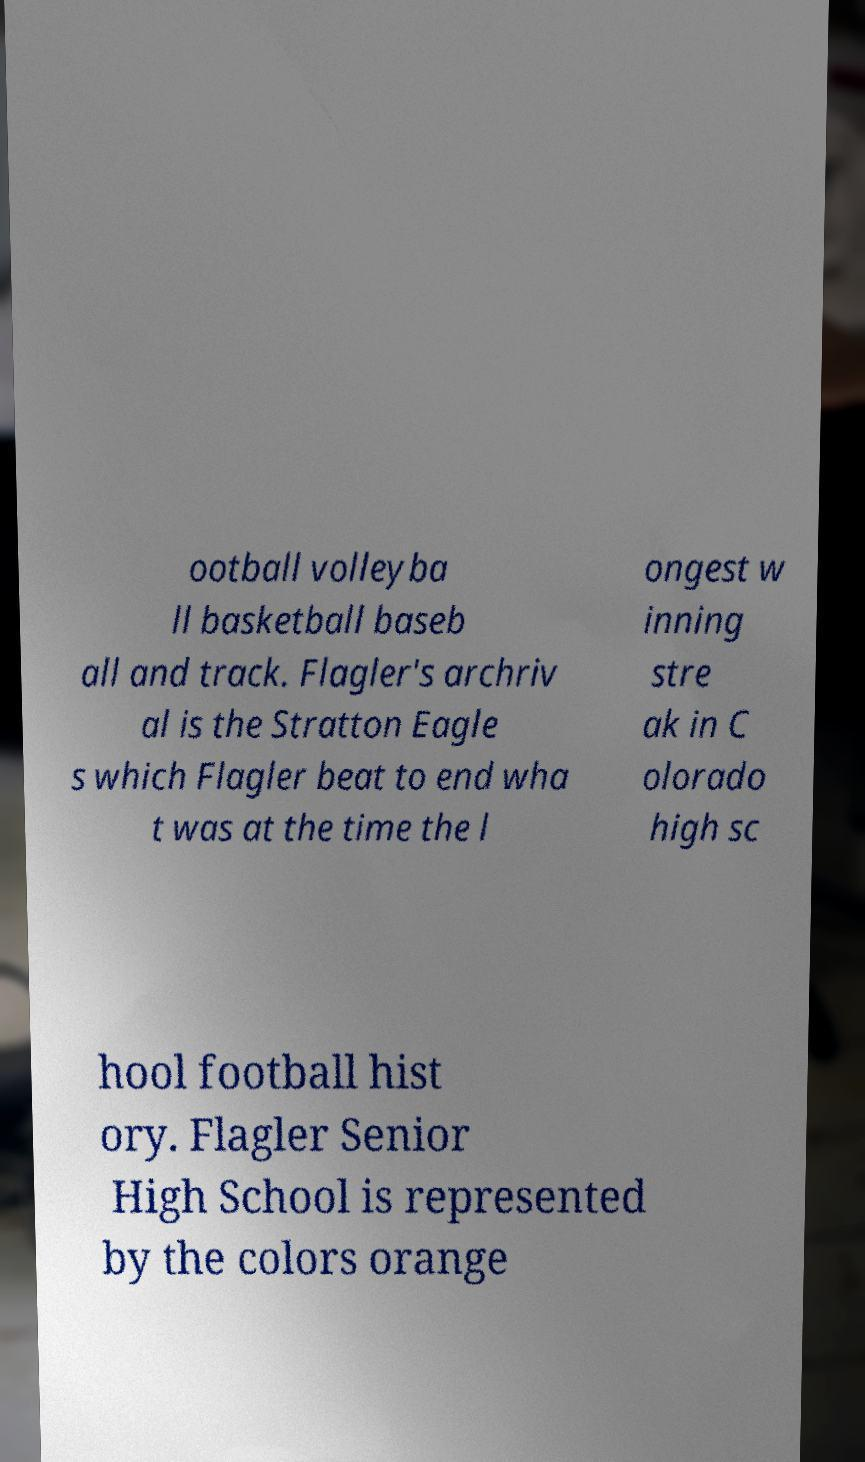Can you read and provide the text displayed in the image?This photo seems to have some interesting text. Can you extract and type it out for me? ootball volleyba ll basketball baseb all and track. Flagler's archriv al is the Stratton Eagle s which Flagler beat to end wha t was at the time the l ongest w inning stre ak in C olorado high sc hool football hist ory. Flagler Senior High School is represented by the colors orange 